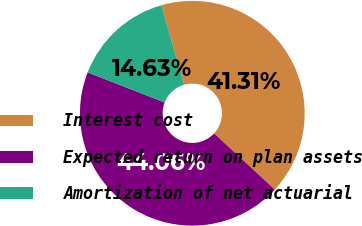<chart> <loc_0><loc_0><loc_500><loc_500><pie_chart><fcel>Interest cost<fcel>Expected return on plan assets<fcel>Amortization of net actuarial<nl><fcel>41.31%<fcel>44.06%<fcel>14.63%<nl></chart> 